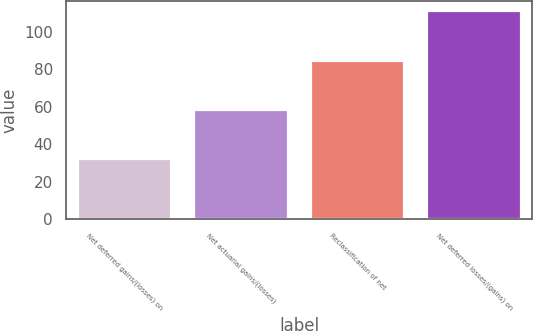Convert chart to OTSL. <chart><loc_0><loc_0><loc_500><loc_500><bar_chart><fcel>Net deferred gains/(losses) on<fcel>Net actuarial gains/(losses)<fcel>Reclassification of net<fcel>Net deferred losses/(gains) on<nl><fcel>32<fcel>58.3<fcel>84.6<fcel>110.9<nl></chart> 